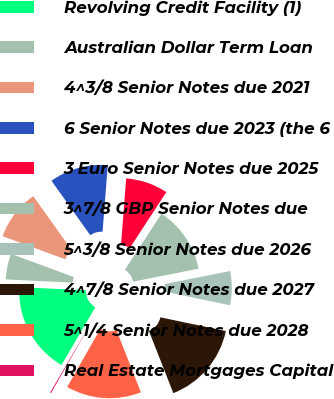Convert chart to OTSL. <chart><loc_0><loc_0><loc_500><loc_500><pie_chart><fcel>Revolving Credit Facility (1)<fcel>Australian Dollar Term Loan<fcel>4^3/8 Senior Notes due 2021<fcel>6 Senior Notes due 2023 (the 6<fcel>3 Euro Senior Notes due 2025<fcel>3^7/8 GBP Senior Notes due<fcel>5^3/8 Senior Notes due 2026<fcel>4^7/8 Senior Notes due 2027<fcel>5^1/4 Senior Notes due 2028<fcel>Real Estate Mortgages Capital<nl><fcel>17.32%<fcel>4.86%<fcel>9.53%<fcel>11.09%<fcel>7.98%<fcel>12.65%<fcel>6.42%<fcel>15.76%<fcel>14.2%<fcel>0.19%<nl></chart> 